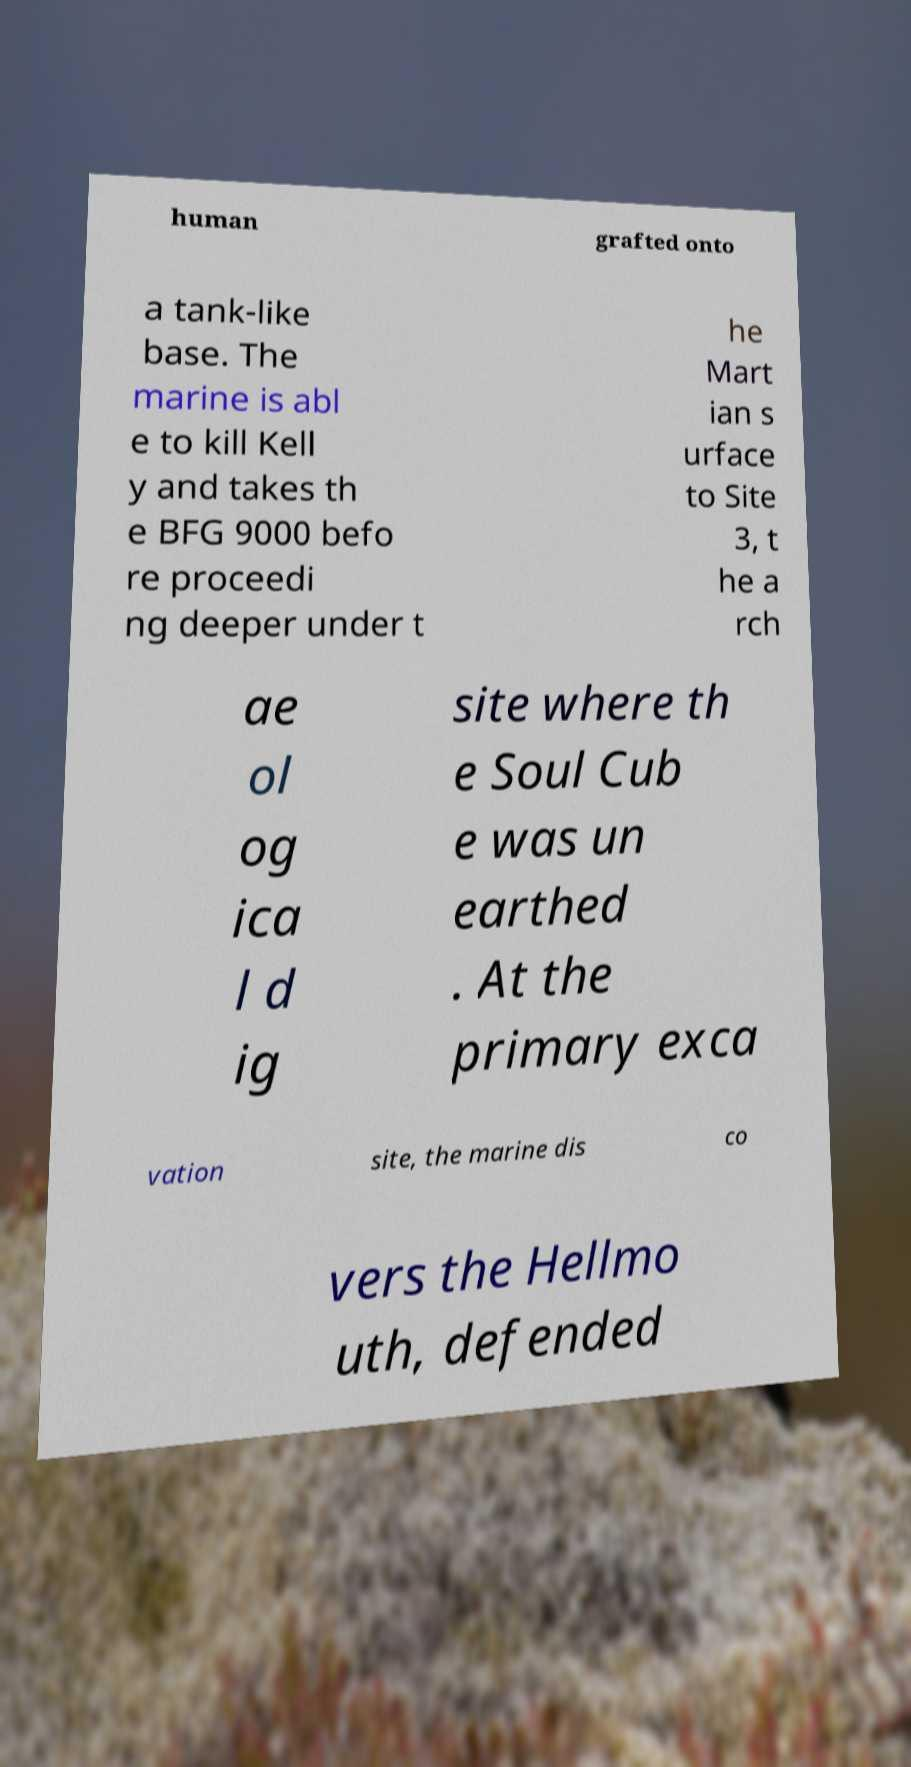Can you read and provide the text displayed in the image?This photo seems to have some interesting text. Can you extract and type it out for me? human grafted onto a tank-like base. The marine is abl e to kill Kell y and takes th e BFG 9000 befo re proceedi ng deeper under t he Mart ian s urface to Site 3, t he a rch ae ol og ica l d ig site where th e Soul Cub e was un earthed . At the primary exca vation site, the marine dis co vers the Hellmo uth, defended 